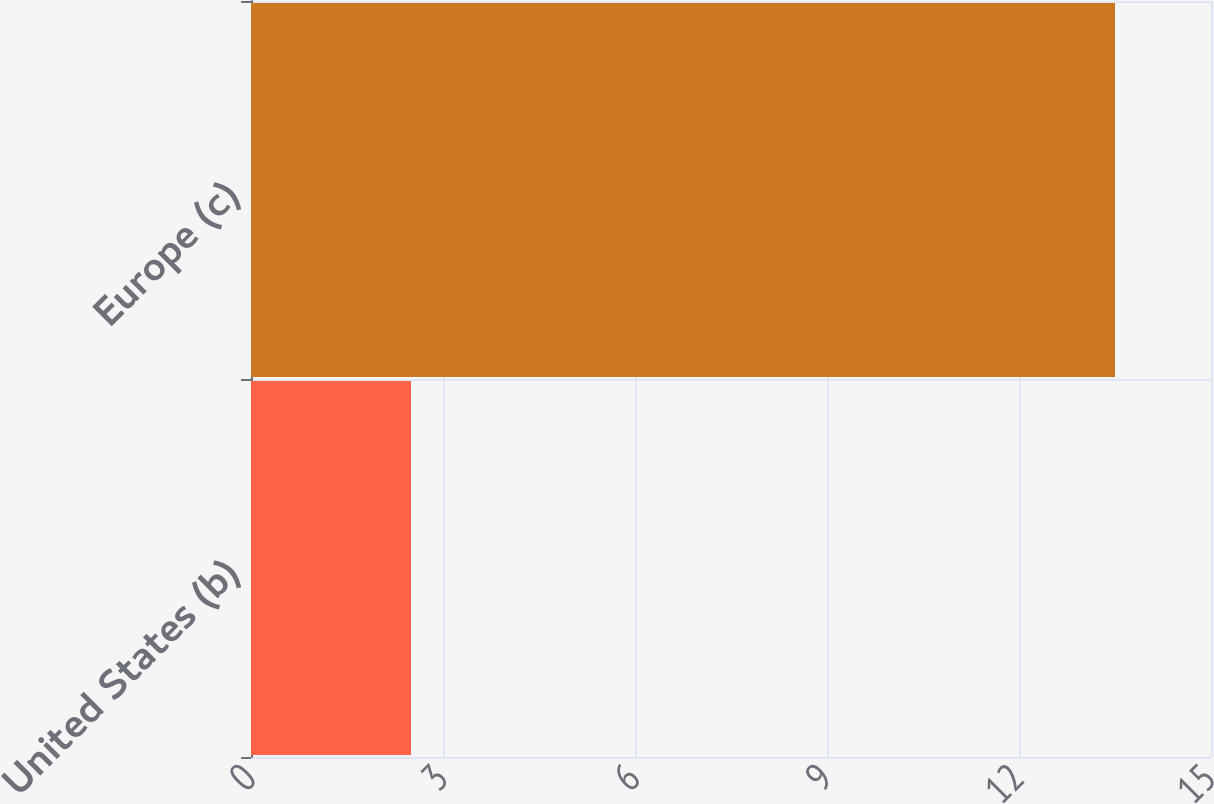<chart> <loc_0><loc_0><loc_500><loc_500><bar_chart><fcel>United States (b)<fcel>Europe (c)<nl><fcel>2.5<fcel>13.5<nl></chart> 